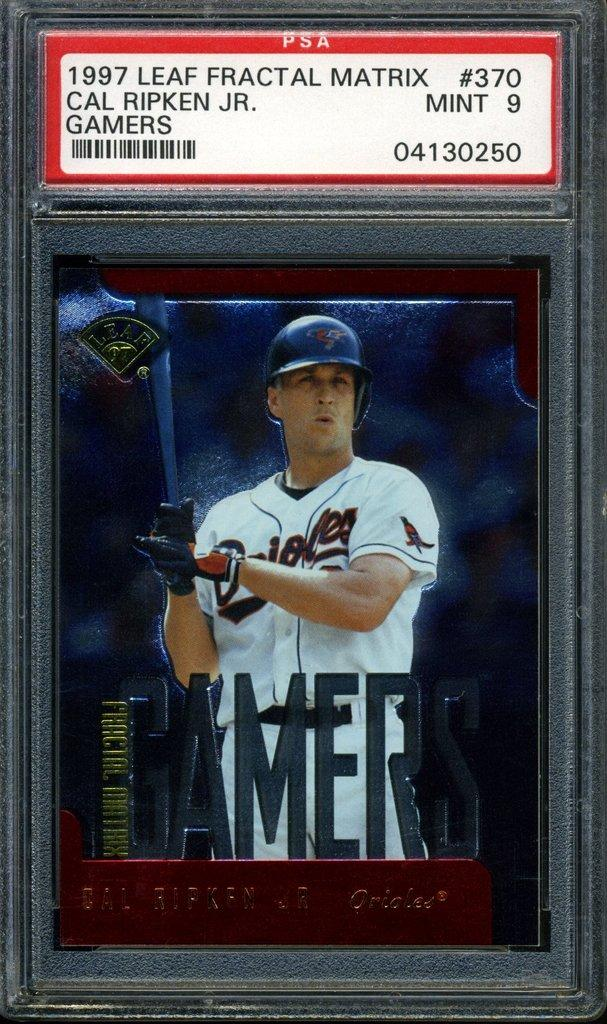<image>
Share a concise interpretation of the image provided. A Cal Ripken baseball card when he played for the Orioles. 